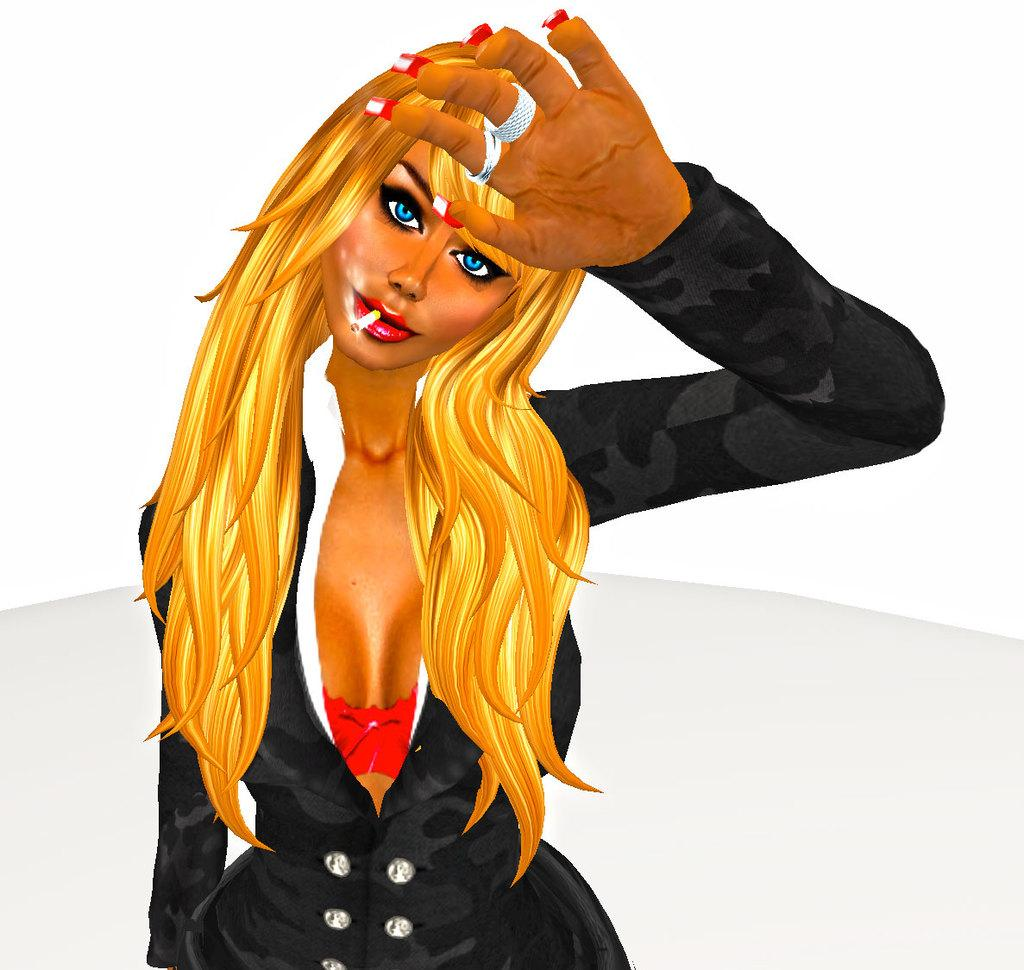What type of image is being described? The image is animated. Can you describe any characters or figures in the image? There is a lady in the image. What can be seen beneath the lady's feet? The ground is visible in the image. What is present in the background of the image? There is a wall in the image. What type of clock is the lady holding in the image? There is no clock present in the image. Can you tell me how the lady is playing the guitar in the image? There is no guitar present in the image. 